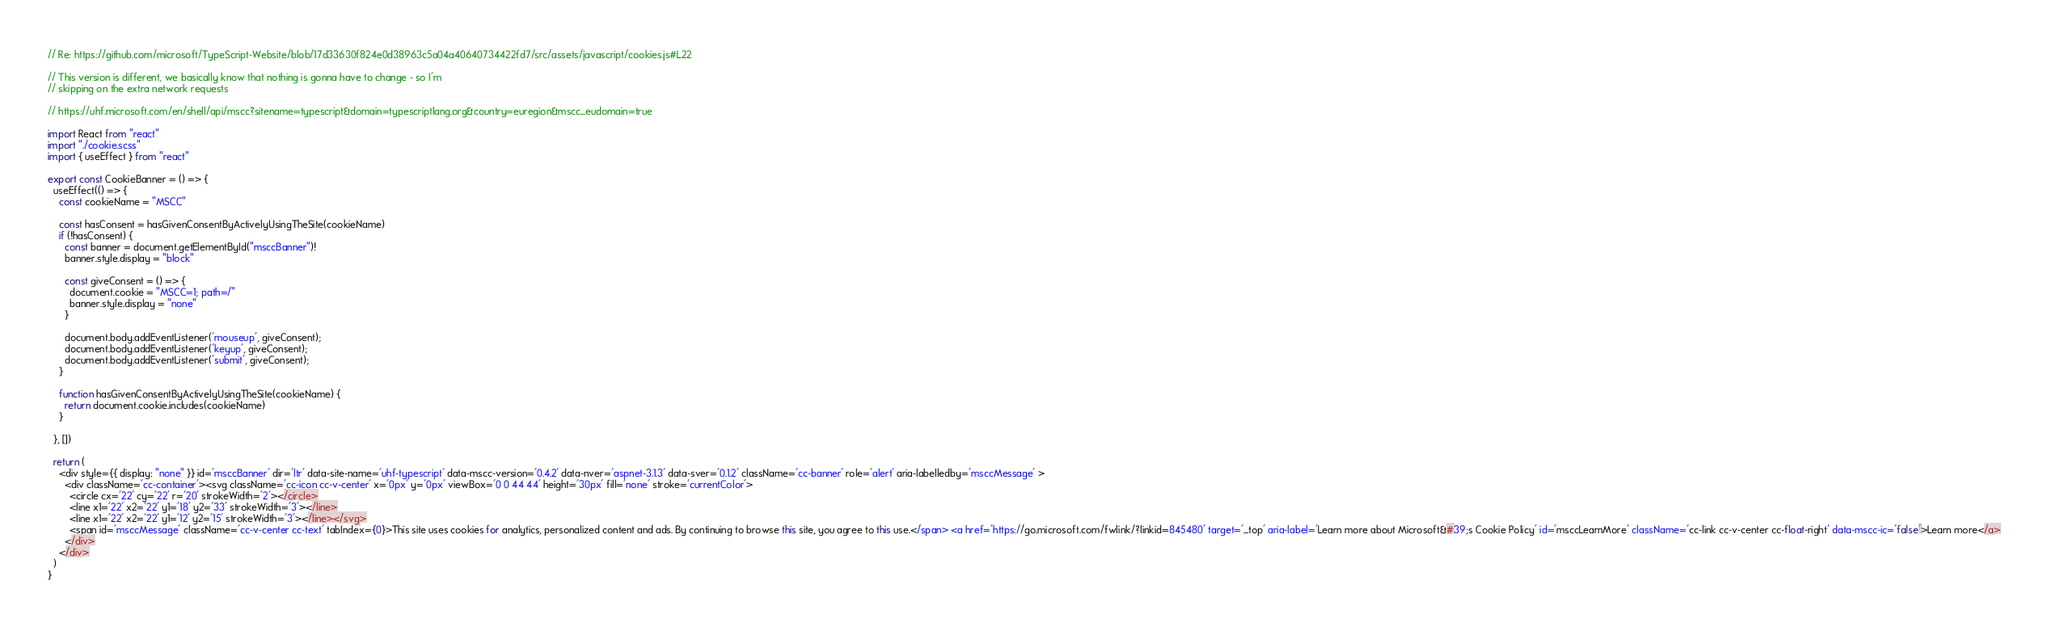<code> <loc_0><loc_0><loc_500><loc_500><_TypeScript_>// Re: https://github.com/microsoft/TypeScript-Website/blob/17d33630f824e0d38963c5a04a40640734422fd7/src/assets/javascript/cookies.js#L22

// This version is different, we basically know that nothing is gonna have to change - so I'm 
// skipping on the extra network requests

// https://uhf.microsoft.com/en/shell/api/mscc?sitename=typescript&domain=typescriptlang.org&country=euregion&mscc_eudomain=true

import React from "react"
import "./cookie.scss"
import { useEffect } from "react"

export const CookieBanner = () => {
  useEffect(() => {
    const cookieName = "MSCC"

    const hasConsent = hasGivenConsentByActivelyUsingTheSite(cookieName)
    if (!hasConsent) {
      const banner = document.getElementById("msccBanner")!
      banner.style.display = "block"

      const giveConsent = () => {
        document.cookie = "MSCC=1; path=/"
        banner.style.display = "none"
      }

      document.body.addEventListener('mouseup', giveConsent);
      document.body.addEventListener('keyup', giveConsent);
      document.body.addEventListener('submit', giveConsent);
    }

    function hasGivenConsentByActivelyUsingTheSite(cookieName) {
      return document.cookie.includes(cookieName)
    }

  }, [])

  return (
    <div style={{ display: "none" }} id='msccBanner' dir='ltr' data-site-name='uhf-typescript' data-mscc-version='0.4.2' data-nver='aspnet-3.1.3' data-sver='0.1.2' className='cc-banner' role='alert' aria-labelledby='msccMessage' >
      <div className='cc-container'><svg className='cc-icon cc-v-center' x='0px' y='0px' viewBox='0 0 44 44' height='30px' fill='none' stroke='currentColor'>
        <circle cx='22' cy='22' r='20' strokeWidth='2'></circle>
        <line x1='22' x2='22' y1='18' y2='33' strokeWidth='3'></line>
        <line x1='22' x2='22' y1='12' y2='15' strokeWidth='3'></line></svg>
        <span id='msccMessage' className='cc-v-center cc-text' tabIndex={0}>This site uses cookies for analytics, personalized content and ads. By continuing to browse this site, you agree to this use.</span> <a href='https://go.microsoft.com/fwlink/?linkid=845480' target='_top' aria-label='Learn more about Microsoft&#39;s Cookie Policy' id='msccLearnMore' className='cc-link cc-v-center cc-float-right' data-mscc-ic='false'>Learn more</a>
      </div>
    </div>
  )
}
</code> 